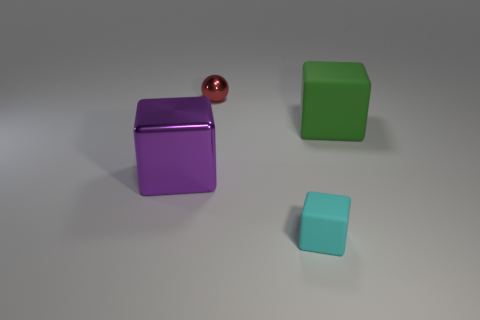The cube that is the same size as the metallic ball is what color?
Make the answer very short. Cyan. Are there any other things that are the same shape as the tiny metal thing?
Provide a succinct answer. No. The big rubber object that is the same shape as the tiny cyan matte object is what color?
Your answer should be very brief. Green. What number of things are tiny metal spheres or cubes to the right of the small metallic ball?
Provide a short and direct response. 3. Are there fewer big matte cubes that are to the left of the red thing than things?
Your answer should be compact. Yes. How big is the matte cube that is behind the large purple shiny block in front of the large thing right of the red metal sphere?
Give a very brief answer. Large. What is the color of the object that is behind the purple shiny cube and to the right of the red metal ball?
Give a very brief answer. Green. How many red balls are there?
Provide a succinct answer. 1. Is the material of the small cube the same as the purple object?
Keep it short and to the point. No. Does the matte object right of the small rubber object have the same size as the shiny thing behind the green block?
Provide a short and direct response. No. 